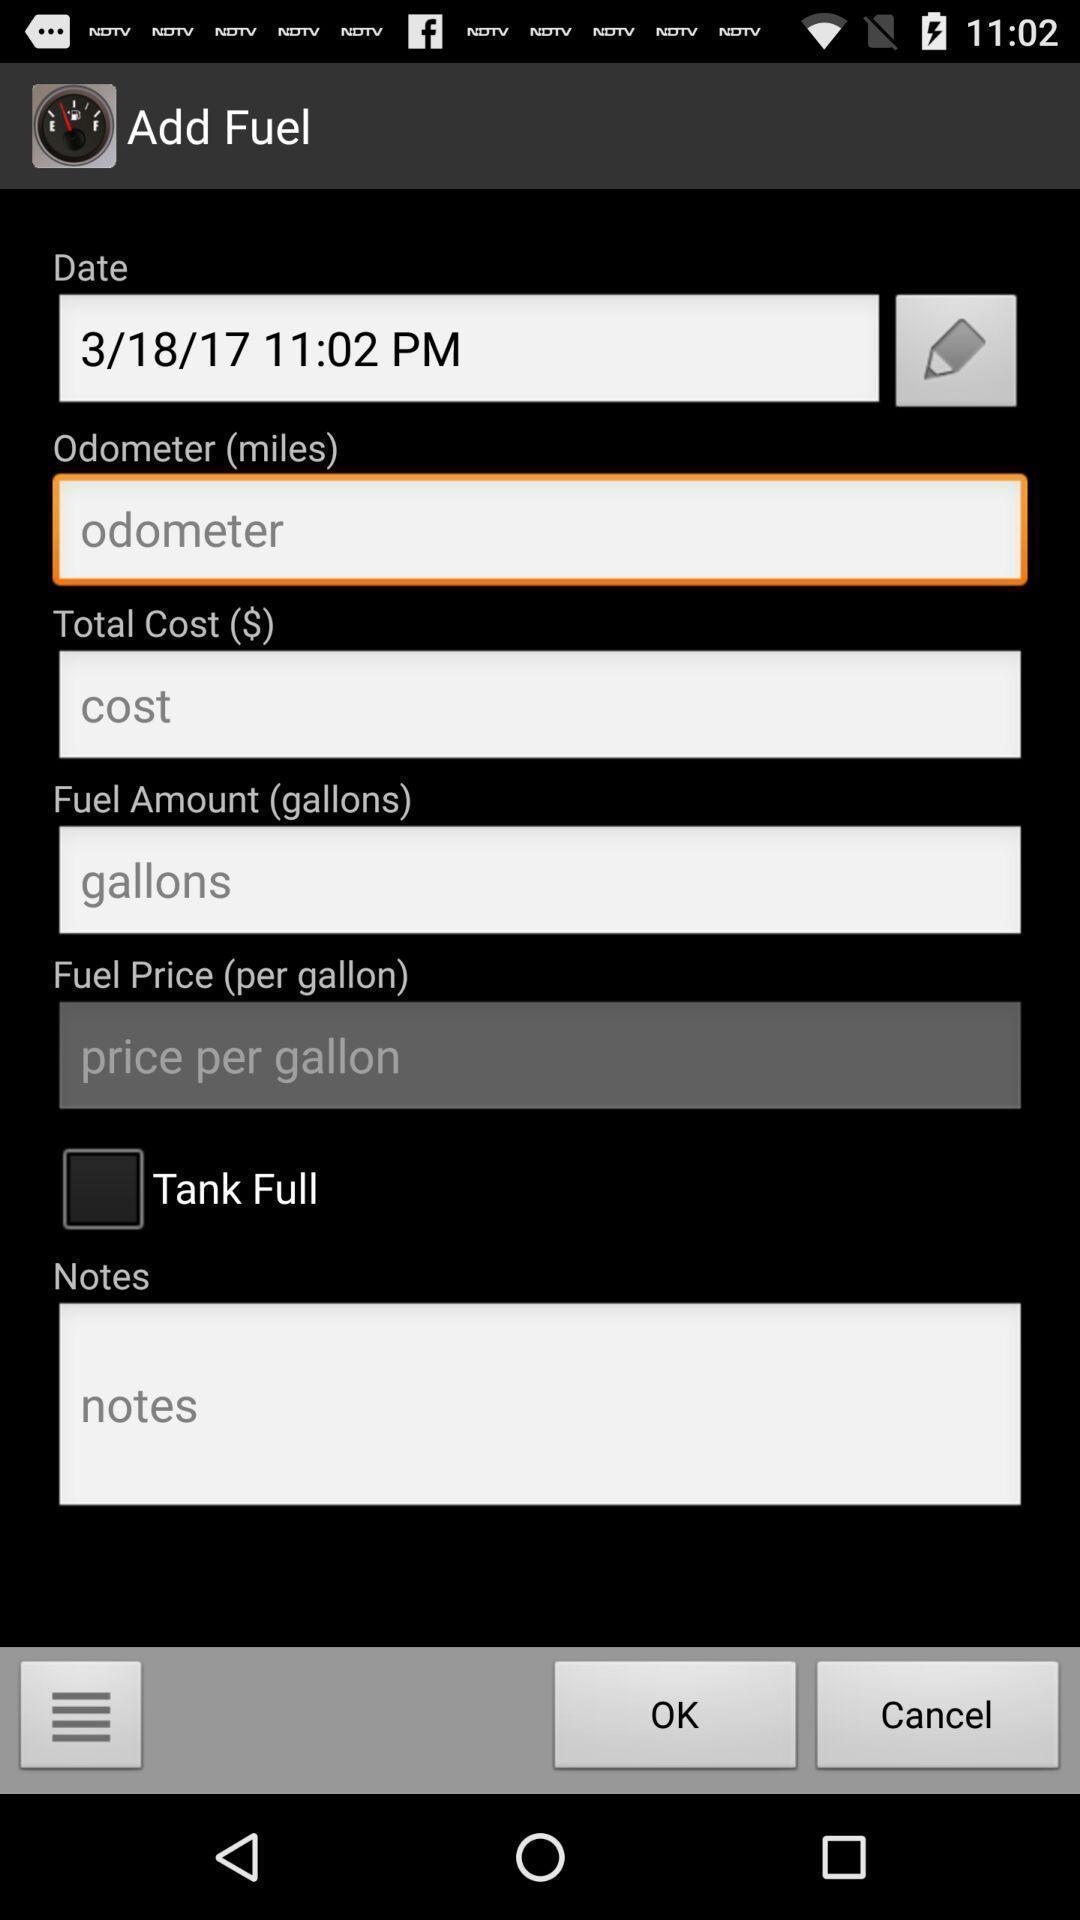Describe the visual elements of this screenshot. Page showing information of fuel. 